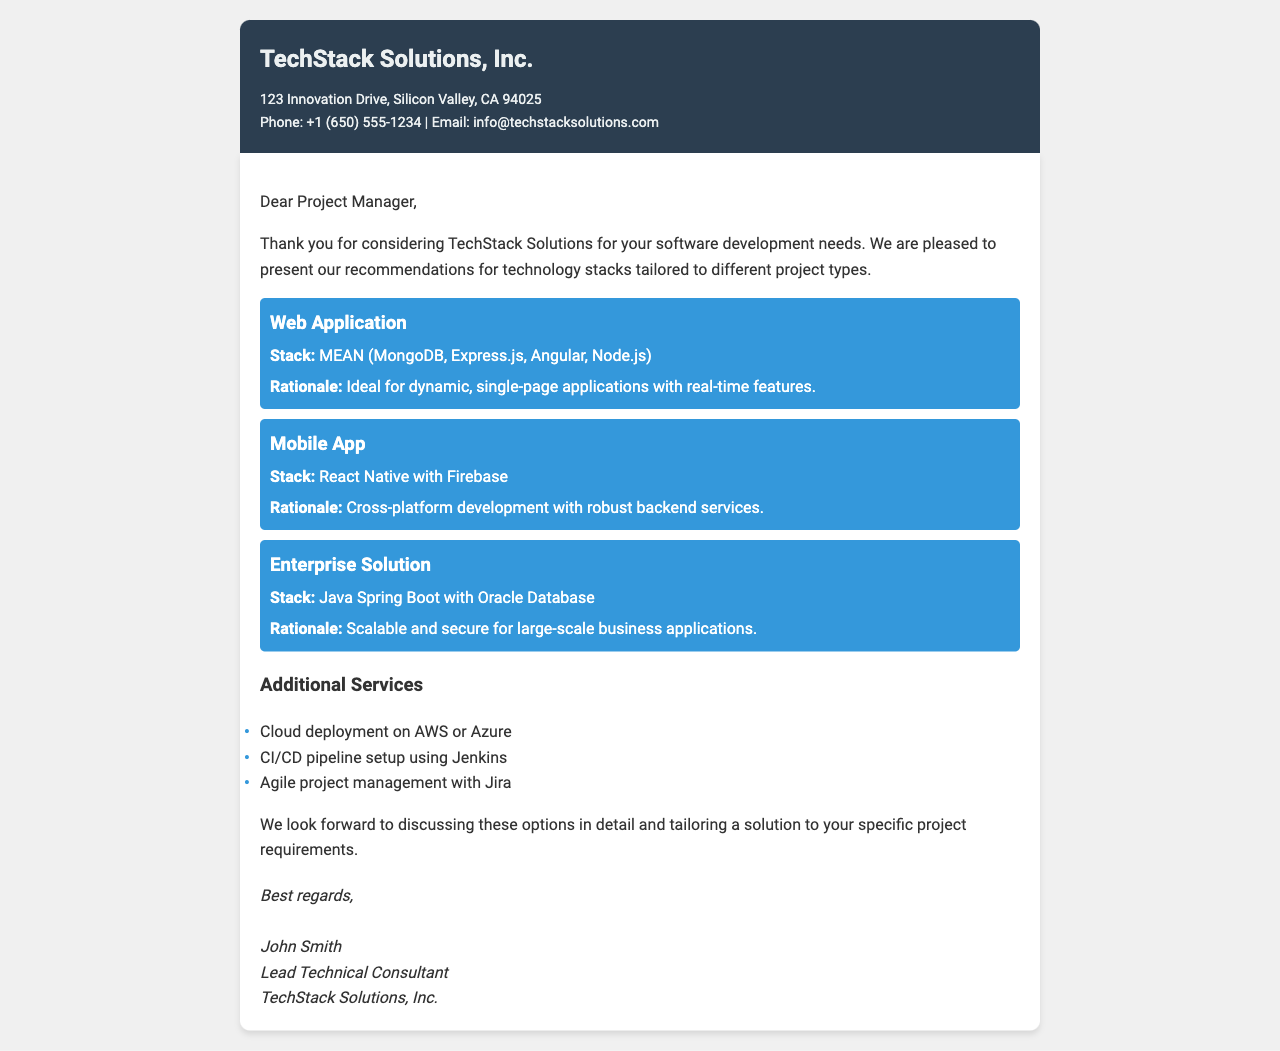What is the name of the consulting firm? The name of the consulting firm is mentioned at the top of the document as TechStack Solutions, Inc.
Answer: TechStack Solutions, Inc What is the address of TechStack Solutions? The address is provided in the contact information section of the document.
Answer: 123 Innovation Drive, Silicon Valley, CA 94025 Which technology stack is recommended for web applications? The document specifies the technology stack recommended for web applications in the corresponding section.
Answer: MEAN (MongoDB, Express.js, Angular, Node.js) What is the rationale for using React Native with Firebase? The rationale for this stack is explained in the mobile app section of the document.
Answer: Cross-platform development with robust backend services How many additional services are listed? The document includes a bulleted list of additional services, which can be counted.
Answer: Three Who is the lead technical consultant? The name of the lead technical consultant is provided in the signature section of the document.
Answer: John Smith What type of application is Java Spring Boot recommended for? The type of application is specified in the enterprise solution section of the document.
Answer: Enterprise Solution What is one of the cloud deployment options mentioned? The document lists cloud deployment options, and one specific option is included.
Answer: AWS or Azure 